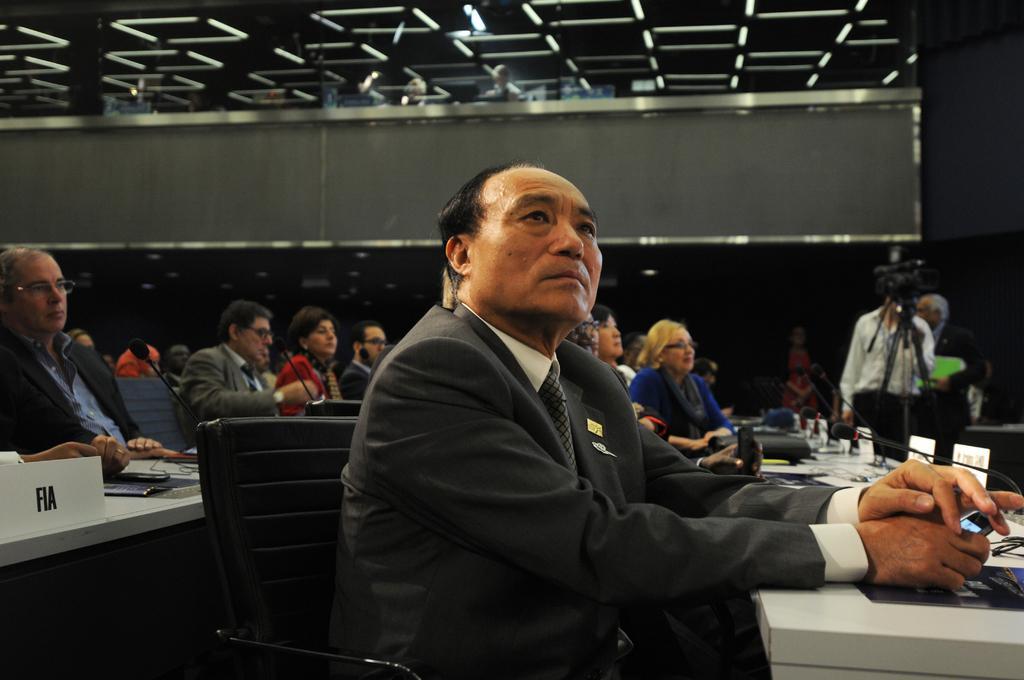How would you summarize this image in a sentence or two? This picture shows the inner view of a building, some chairs, some tables, few objects on the ground, one camera with stand, some microphones attached to the tables, some objects on the tables, it looks like one glass wall, some people are sitting on the chairs, some people are holding objects, three people are standing, two batches attached to the black coat of a man in the middle of the image and the background is dark. 